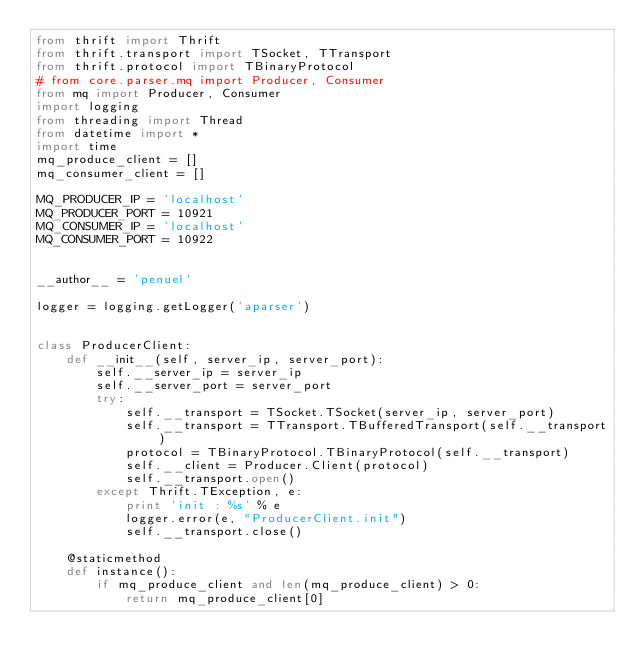<code> <loc_0><loc_0><loc_500><loc_500><_Python_>from thrift import Thrift
from thrift.transport import TSocket, TTransport
from thrift.protocol import TBinaryProtocol
# from core.parser.mq import Producer, Consumer
from mq import Producer, Consumer
import logging
from threading import Thread
from datetime import *
import time
mq_produce_client = []
mq_consumer_client = []

MQ_PRODUCER_IP = 'localhost'
MQ_PRODUCER_PORT = 10921
MQ_CONSUMER_IP = 'localhost'
MQ_CONSUMER_PORT = 10922


__author__ = 'penuel'

logger = logging.getLogger('aparser')


class ProducerClient:
    def __init__(self, server_ip, server_port):
        self.__server_ip = server_ip
        self.__server_port = server_port
        try:
            self.__transport = TSocket.TSocket(server_ip, server_port)
            self.__transport = TTransport.TBufferedTransport(self.__transport)
            protocol = TBinaryProtocol.TBinaryProtocol(self.__transport)
            self.__client = Producer.Client(protocol)
            self.__transport.open()
        except Thrift.TException, e:
            print 'init : %s' % e
            logger.error(e, "ProducerClient.init")
            self.__transport.close()

    @staticmethod
    def instance():
        if mq_produce_client and len(mq_produce_client) > 0:
            return mq_produce_client[0]</code> 